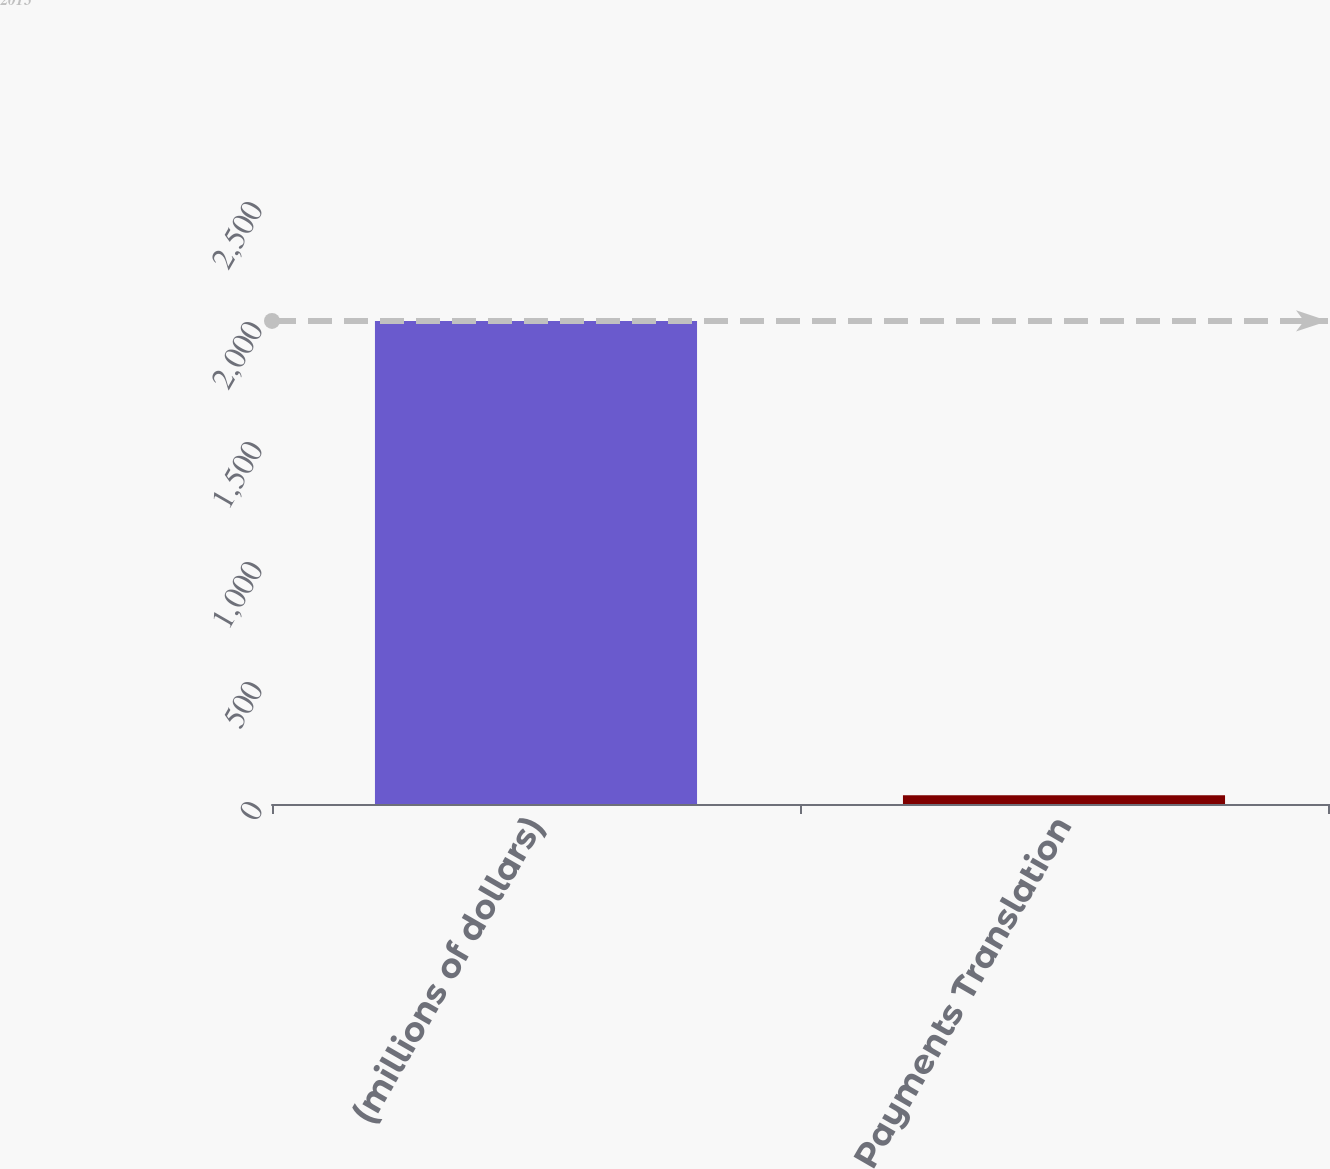Convert chart to OTSL. <chart><loc_0><loc_0><loc_500><loc_500><bar_chart><fcel>(millions of dollars)<fcel>Payments Translation<nl><fcel>2013<fcel>36.7<nl></chart> 